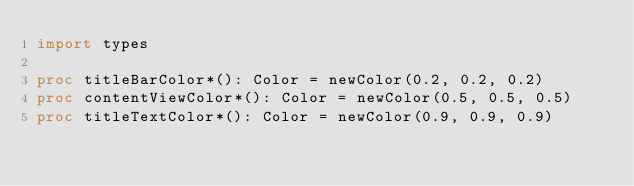Convert code to text. <code><loc_0><loc_0><loc_500><loc_500><_Nim_>import types

proc titleBarColor*(): Color = newColor(0.2, 0.2, 0.2)
proc contentViewColor*(): Color = newColor(0.5, 0.5, 0.5)
proc titleTextColor*(): Color = newColor(0.9, 0.9, 0.9)
</code> 